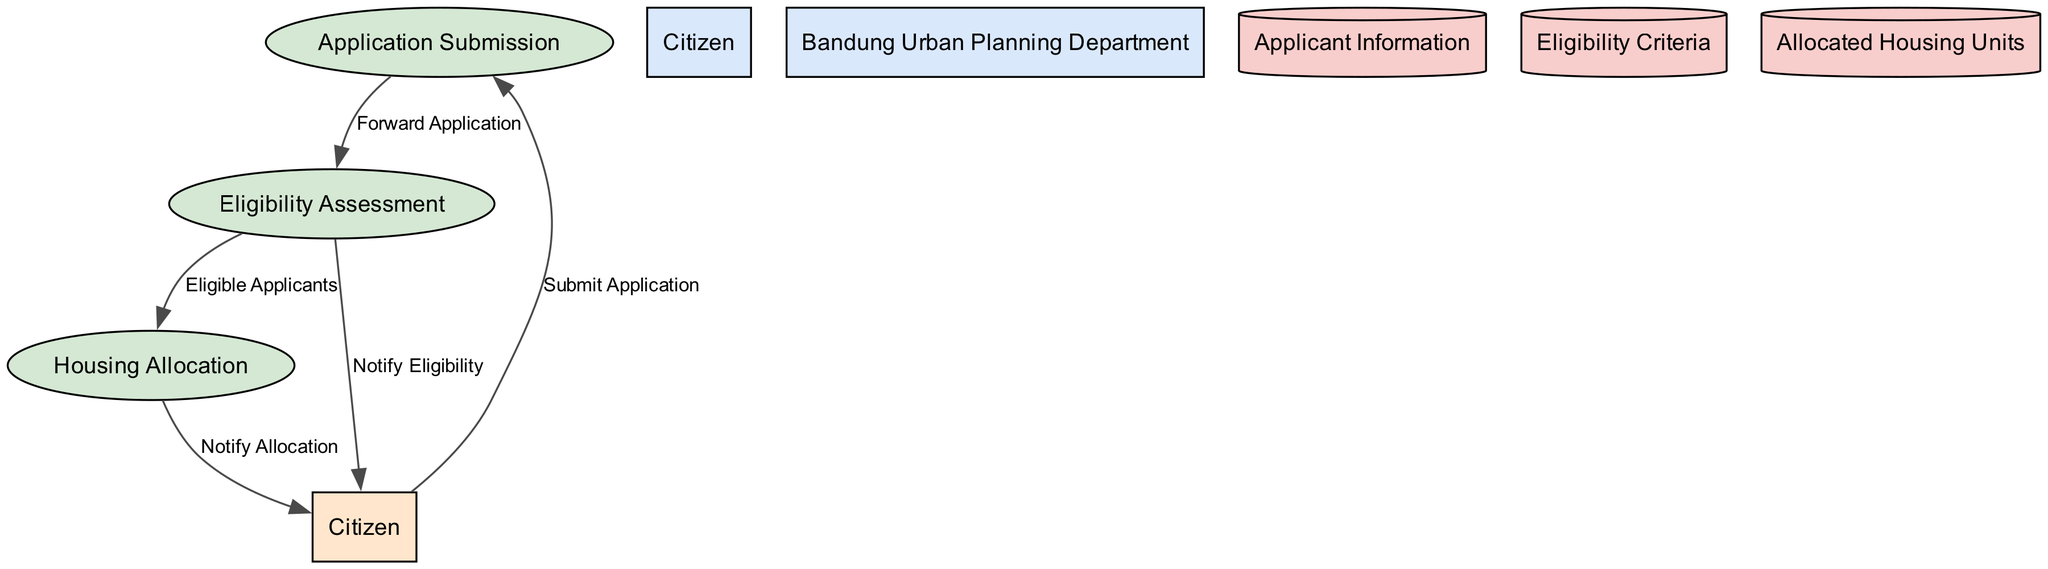What is the first process in the diagram? The first process listed in the diagram is "Application Submission." This can be identified by looking at the processes section, which starts with P1.
Answer: Application Submission How many data flows are present in the diagram? To determine the number of data flows, you can count the items in the data_flows section. There are five data flows listed.
Answer: 5 Who submits the application? The application is submitted by the "Citizen," which is indicated at the beginning of the data flow that connects to the Application Submission process.
Answer: Citizen What does the Eligibility Assessment process yield? The Eligibility Assessment process yields "Eligible Applicants," which is indicated in the data flows where P2 connects to P3.
Answer: Eligible Applicants What is the destination of the data flow from P2 to the Citizen? The data flow from P2 (Eligibility Assessment) to the Citizen is labeled "Notify Eligibility," indicating the response after assessing eligibility.
Answer: Notify Eligibility Which external entity is involved in the process? The diagram indicates that there are two external entities, but one of them, specifically the focused external entity in relation to the process, is "Citizen." This is confirmed by the connections leading to and from the Citizen in the data flows.
Answer: Citizen How are the allocated housing units stored? The allocated housing units are stored in the "Allocated Housing Units," which is indicated as a data store in the diagram denoted by D3.
Answer: Allocated Housing Units What is the outcome of the housing allocation process? The outcome of the housing allocation process is "Notify Allocation," as indicated by the data flow that connects P3 to the Citizen. This signifies the end of the allocation process.
Answer: Notify Allocation Which process follows after the forward application in the diagram? After the "Forward Application" from Process P1, the next process is "Eligibility Assessment" denoted as P2. This is based on the direction of the data flow from P1 to P2.
Answer: Eligibility Assessment 